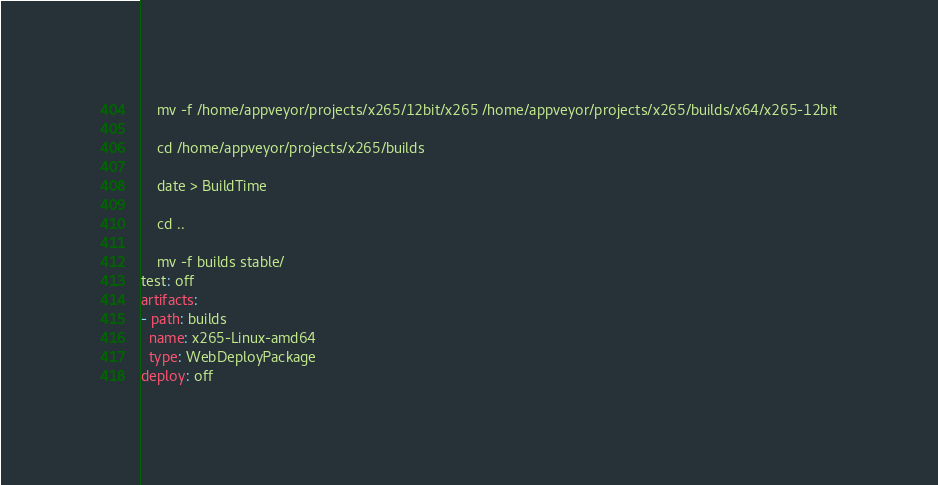<code> <loc_0><loc_0><loc_500><loc_500><_YAML_>
    mv -f /home/appveyor/projects/x265/12bit/x265 /home/appveyor/projects/x265/builds/x64/x265-12bit

    cd /home/appveyor/projects/x265/builds

    date > BuildTime

    cd ..

    mv -f builds stable/
test: off
artifacts:
- path: builds
  name: x265-Linux-amd64
  type: WebDeployPackage
deploy: off</code> 